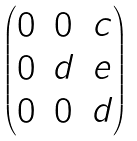Convert formula to latex. <formula><loc_0><loc_0><loc_500><loc_500>\begin{pmatrix} 0 & 0 & c \\ 0 & d & e \\ 0 & 0 & d \end{pmatrix}</formula> 